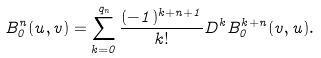<formula> <loc_0><loc_0><loc_500><loc_500>B ^ { n } _ { 0 } ( u , v ) = \sum _ { k = 0 } ^ { q _ { n } } \frac { ( - 1 ) ^ { k + n + 1 } } { k ! } D ^ { k } B ^ { k + n } _ { 0 } ( v , u ) .</formula> 